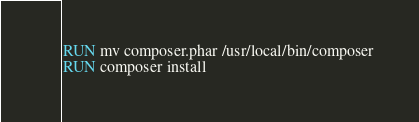<code> <loc_0><loc_0><loc_500><loc_500><_Dockerfile_>RUN mv composer.phar /usr/local/bin/composer
RUN composer install
</code> 